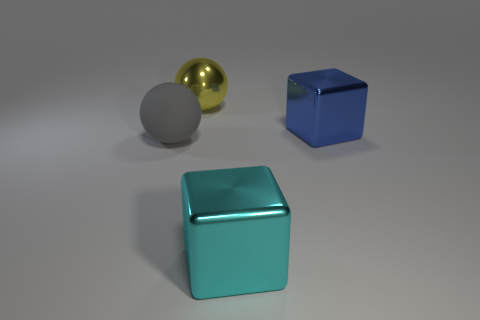Add 2 metal spheres. How many objects exist? 6 Subtract 1 spheres. How many spheres are left? 1 Add 2 big rubber balls. How many big rubber balls are left? 3 Add 3 big green matte cylinders. How many big green matte cylinders exist? 3 Subtract 0 cyan spheres. How many objects are left? 4 Subtract all big cyan metal objects. Subtract all matte spheres. How many objects are left? 2 